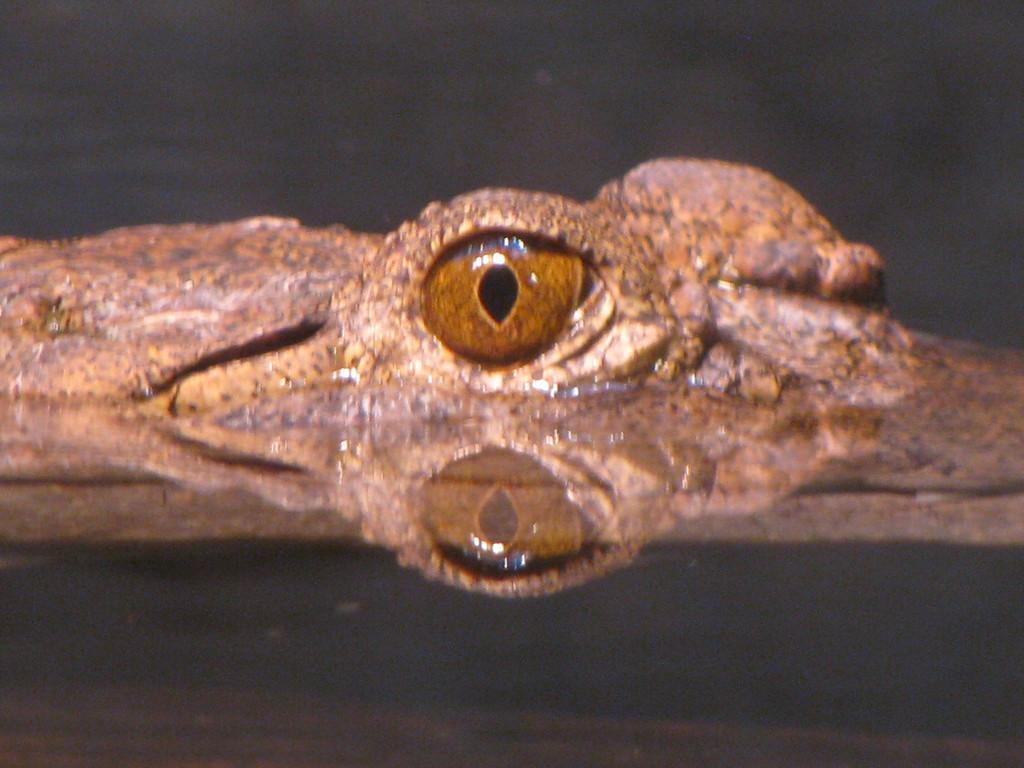Could you give a brief overview of what you see in this image? In the picture we can see water on the top of it we can see a part of reptile with a eye. 